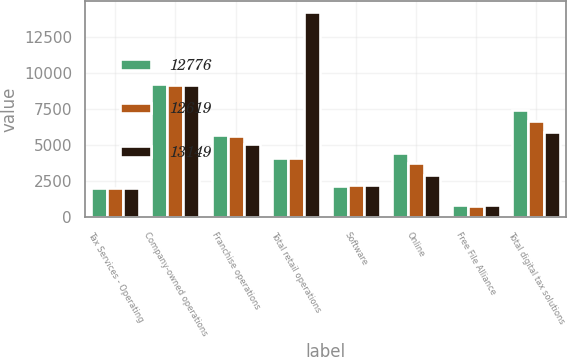Convert chart to OTSL. <chart><loc_0><loc_0><loc_500><loc_500><stacked_bar_chart><ecel><fcel>Tax Services - Operating<fcel>Company-owned operations<fcel>Franchise operations<fcel>Total retail operations<fcel>Software<fcel>Online<fcel>Free File Alliance<fcel>Total digital tax solutions<nl><fcel>12776<fcel>2012<fcel>9207<fcel>5693<fcel>4070.5<fcel>2158<fcel>4419<fcel>861<fcel>7438<nl><fcel>12619<fcel>2011<fcel>9168<fcel>5588<fcel>4070.5<fcel>2201<fcel>3722<fcel>767<fcel>6690<nl><fcel>13149<fcel>2010<fcel>9182<fcel>5064<fcel>14246<fcel>2193<fcel>2893<fcel>810<fcel>5896<nl></chart> 